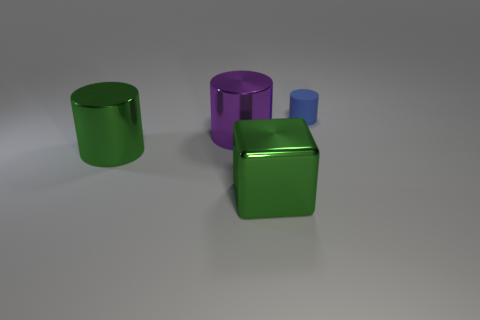Add 3 purple things. How many objects exist? 7 Subtract all tiny blue matte cylinders. How many cylinders are left? 2 Subtract all cubes. How many objects are left? 3 Subtract all blue cylinders. How many cylinders are left? 2 Subtract 2 cylinders. How many cylinders are left? 1 Subtract all yellow cubes. Subtract all cyan cylinders. How many cubes are left? 1 Subtract all blue blocks. How many green cylinders are left? 1 Subtract all blue rubber cylinders. Subtract all large purple shiny things. How many objects are left? 2 Add 3 tiny cylinders. How many tiny cylinders are left? 4 Add 2 large purple metal blocks. How many large purple metal blocks exist? 2 